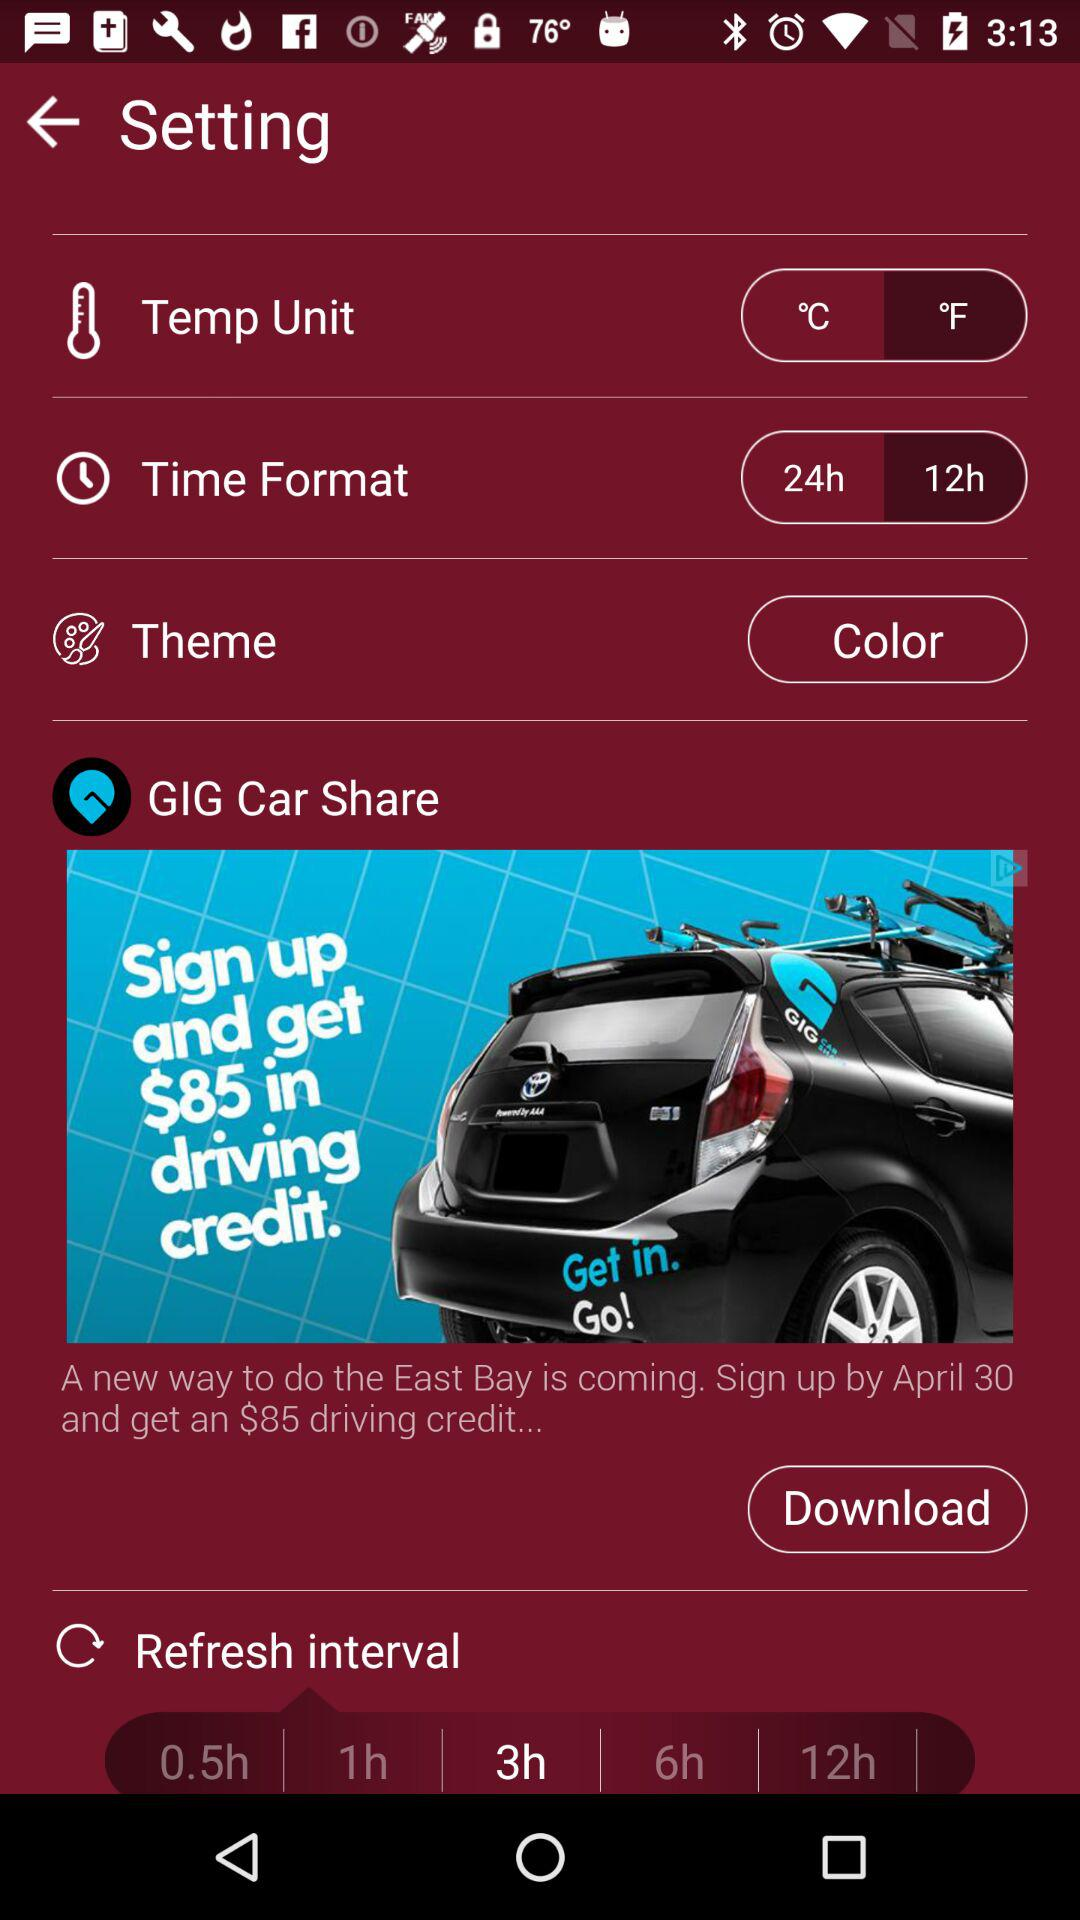What is the selected temperature unit? In the image, the temperature unit is set to degrees Fahrenheit, denoted by '°F'. This is a common temperature scale used in the United States and some other regions. 